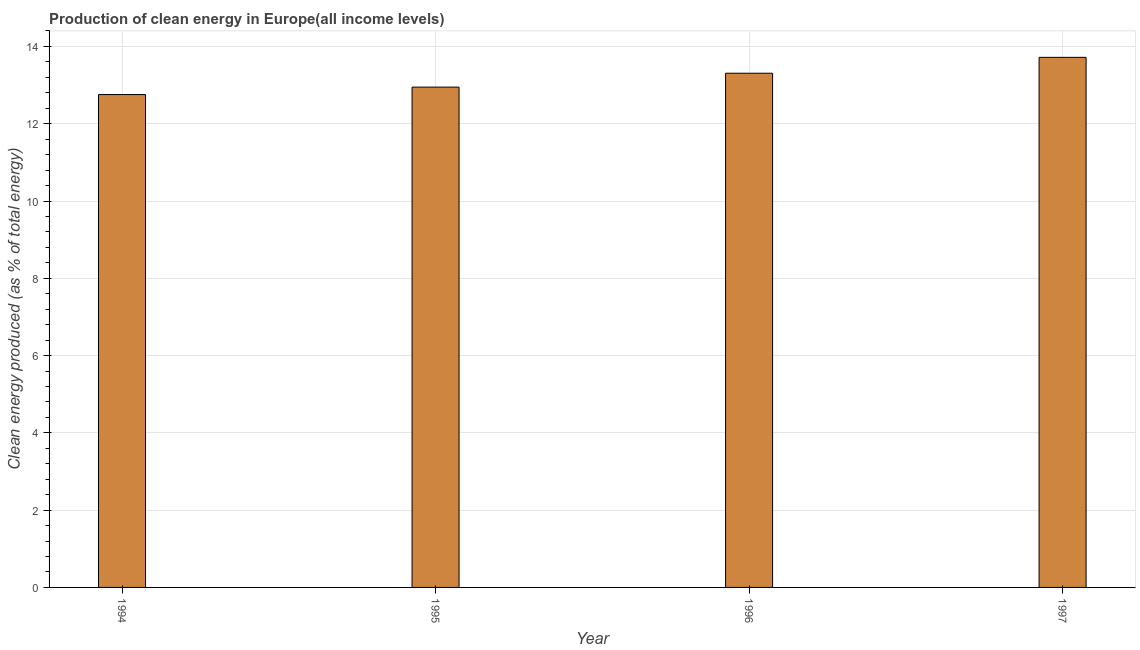What is the title of the graph?
Provide a short and direct response. Production of clean energy in Europe(all income levels). What is the label or title of the Y-axis?
Keep it short and to the point. Clean energy produced (as % of total energy). What is the production of clean energy in 1997?
Offer a terse response. 13.72. Across all years, what is the maximum production of clean energy?
Offer a terse response. 13.72. Across all years, what is the minimum production of clean energy?
Offer a very short reply. 12.75. In which year was the production of clean energy maximum?
Provide a succinct answer. 1997. In which year was the production of clean energy minimum?
Offer a very short reply. 1994. What is the sum of the production of clean energy?
Give a very brief answer. 52.73. What is the difference between the production of clean energy in 1995 and 1997?
Offer a terse response. -0.77. What is the average production of clean energy per year?
Offer a very short reply. 13.18. What is the median production of clean energy?
Provide a succinct answer. 13.13. In how many years, is the production of clean energy greater than 0.8 %?
Offer a very short reply. 4. Do a majority of the years between 1995 and 1996 (inclusive) have production of clean energy greater than 14 %?
Your response must be concise. No. Is the production of clean energy in 1995 less than that in 1997?
Make the answer very short. Yes. What is the difference between the highest and the second highest production of clean energy?
Make the answer very short. 0.41. What is the difference between the highest and the lowest production of clean energy?
Keep it short and to the point. 0.96. How many years are there in the graph?
Make the answer very short. 4. What is the difference between two consecutive major ticks on the Y-axis?
Offer a terse response. 2. What is the Clean energy produced (as % of total energy) in 1994?
Your response must be concise. 12.75. What is the Clean energy produced (as % of total energy) of 1995?
Your answer should be compact. 12.95. What is the Clean energy produced (as % of total energy) in 1996?
Offer a terse response. 13.31. What is the Clean energy produced (as % of total energy) in 1997?
Your answer should be compact. 13.72. What is the difference between the Clean energy produced (as % of total energy) in 1994 and 1995?
Make the answer very short. -0.19. What is the difference between the Clean energy produced (as % of total energy) in 1994 and 1996?
Your response must be concise. -0.55. What is the difference between the Clean energy produced (as % of total energy) in 1994 and 1997?
Offer a terse response. -0.96. What is the difference between the Clean energy produced (as % of total energy) in 1995 and 1996?
Your response must be concise. -0.36. What is the difference between the Clean energy produced (as % of total energy) in 1995 and 1997?
Give a very brief answer. -0.77. What is the difference between the Clean energy produced (as % of total energy) in 1996 and 1997?
Ensure brevity in your answer.  -0.41. What is the ratio of the Clean energy produced (as % of total energy) in 1995 to that in 1996?
Your response must be concise. 0.97. What is the ratio of the Clean energy produced (as % of total energy) in 1995 to that in 1997?
Provide a short and direct response. 0.94. 